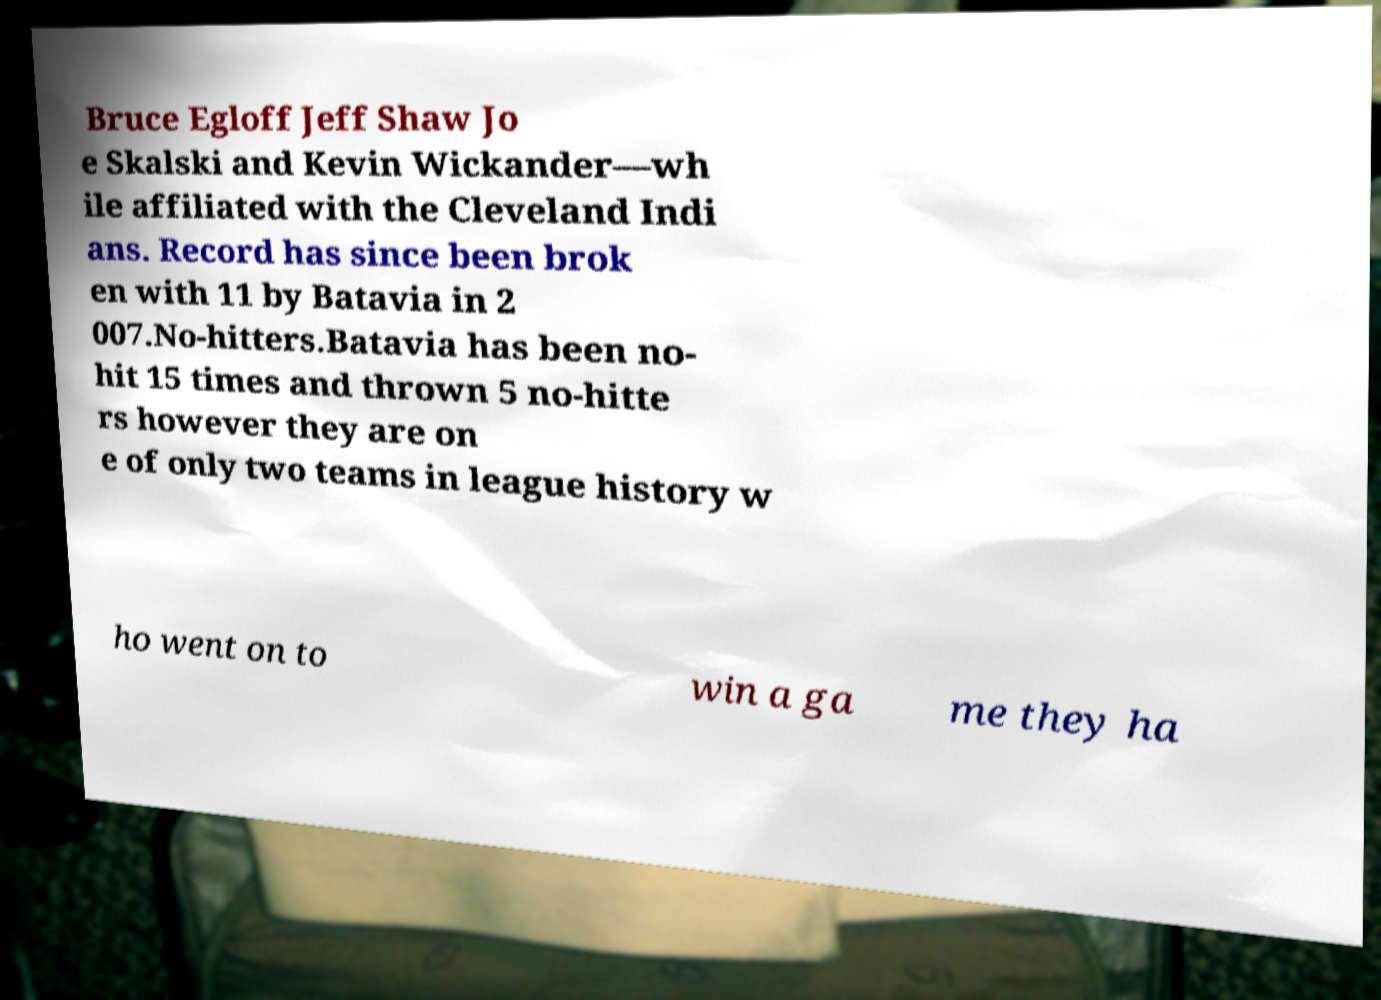For documentation purposes, I need the text within this image transcribed. Could you provide that? Bruce Egloff Jeff Shaw Jo e Skalski and Kevin Wickander—wh ile affiliated with the Cleveland Indi ans. Record has since been brok en with 11 by Batavia in 2 007.No-hitters.Batavia has been no- hit 15 times and thrown 5 no-hitte rs however they are on e of only two teams in league history w ho went on to win a ga me they ha 